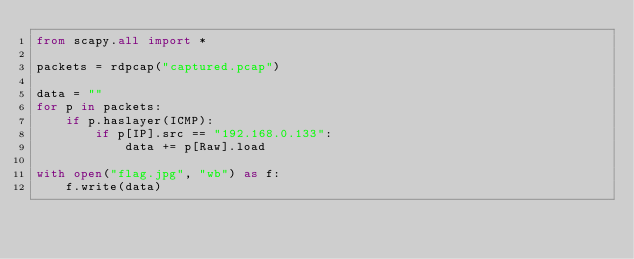Convert code to text. <code><loc_0><loc_0><loc_500><loc_500><_Python_>from scapy.all import *

packets = rdpcap("captured.pcap")

data = ""
for p in packets:
    if p.haslayer(ICMP):
        if p[IP].src == "192.168.0.133":
            data += p[Raw].load

with open("flag.jpg", "wb") as f:
    f.write(data)
</code> 